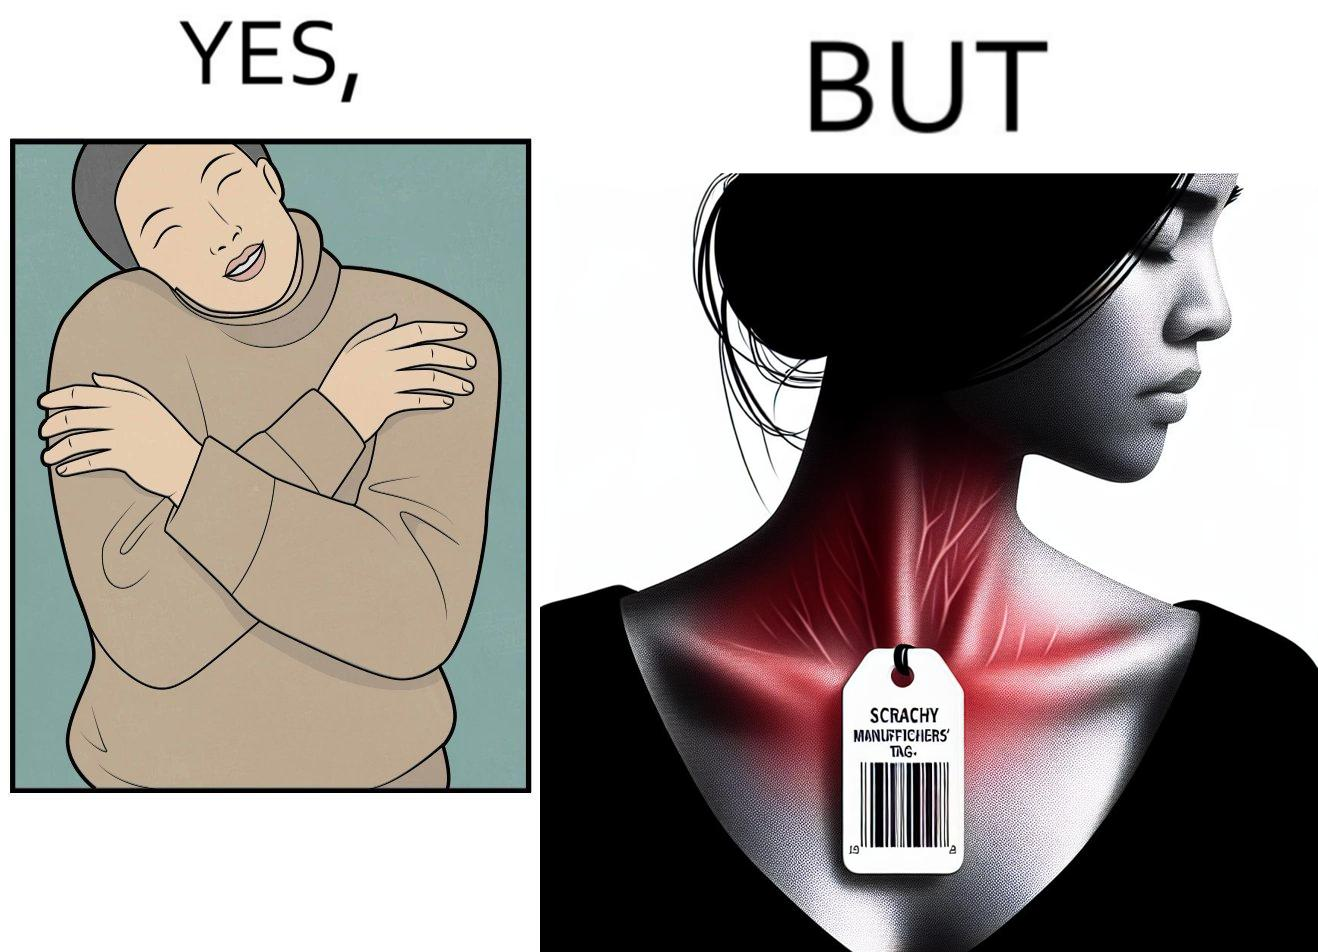Describe what you see in the left and right parts of this image. In the left part of the image: It is a woman enjoying the warmth and comfort of her sweater In the right part of the image: It a womans neck, irritated and red due to manufacturers tags on her clothes 